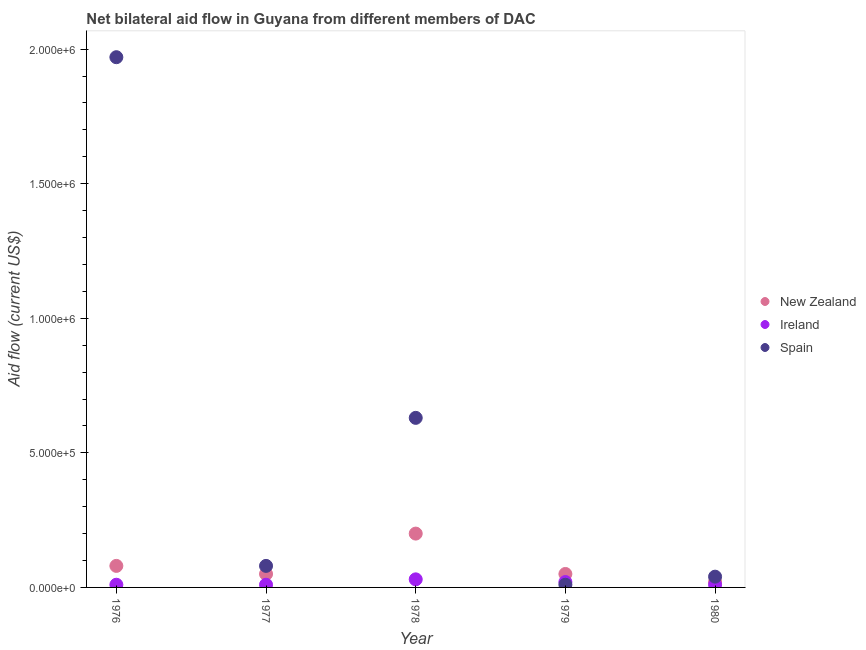How many different coloured dotlines are there?
Ensure brevity in your answer.  3. Is the number of dotlines equal to the number of legend labels?
Keep it short and to the point. Yes. What is the amount of aid provided by ireland in 1978?
Give a very brief answer. 3.00e+04. Across all years, what is the maximum amount of aid provided by ireland?
Keep it short and to the point. 3.00e+04. Across all years, what is the minimum amount of aid provided by new zealand?
Your response must be concise. 2.00e+04. In which year was the amount of aid provided by spain maximum?
Your answer should be very brief. 1976. What is the total amount of aid provided by new zealand in the graph?
Provide a short and direct response. 4.00e+05. What is the difference between the amount of aid provided by ireland in 1977 and that in 1979?
Make the answer very short. -10000. What is the difference between the amount of aid provided by ireland in 1979 and the amount of aid provided by spain in 1980?
Give a very brief answer. -2.00e+04. In the year 1977, what is the difference between the amount of aid provided by new zealand and amount of aid provided by spain?
Offer a very short reply. -3.00e+04. In how many years, is the amount of aid provided by new zealand greater than 500000 US$?
Provide a short and direct response. 0. What is the ratio of the amount of aid provided by ireland in 1976 to that in 1977?
Your response must be concise. 1. Is the amount of aid provided by ireland in 1978 less than that in 1979?
Your answer should be compact. No. Is the difference between the amount of aid provided by ireland in 1978 and 1980 greater than the difference between the amount of aid provided by new zealand in 1978 and 1980?
Make the answer very short. No. What is the difference between the highest and the lowest amount of aid provided by new zealand?
Make the answer very short. 1.80e+05. Is the sum of the amount of aid provided by new zealand in 1977 and 1978 greater than the maximum amount of aid provided by ireland across all years?
Offer a very short reply. Yes. Is it the case that in every year, the sum of the amount of aid provided by new zealand and amount of aid provided by ireland is greater than the amount of aid provided by spain?
Your answer should be very brief. No. Is the amount of aid provided by ireland strictly greater than the amount of aid provided by new zealand over the years?
Your answer should be very brief. No. Is the amount of aid provided by ireland strictly less than the amount of aid provided by spain over the years?
Provide a succinct answer. No. How many dotlines are there?
Give a very brief answer. 3. How many years are there in the graph?
Provide a succinct answer. 5. How many legend labels are there?
Offer a very short reply. 3. How are the legend labels stacked?
Your response must be concise. Vertical. What is the title of the graph?
Provide a short and direct response. Net bilateral aid flow in Guyana from different members of DAC. Does "Ages 50+" appear as one of the legend labels in the graph?
Your response must be concise. No. What is the label or title of the X-axis?
Ensure brevity in your answer.  Year. What is the Aid flow (current US$) in New Zealand in 1976?
Give a very brief answer. 8.00e+04. What is the Aid flow (current US$) of Ireland in 1976?
Provide a succinct answer. 10000. What is the Aid flow (current US$) in Spain in 1976?
Make the answer very short. 1.97e+06. What is the Aid flow (current US$) in New Zealand in 1977?
Ensure brevity in your answer.  5.00e+04. What is the Aid flow (current US$) of Spain in 1977?
Offer a terse response. 8.00e+04. What is the Aid flow (current US$) in New Zealand in 1978?
Give a very brief answer. 2.00e+05. What is the Aid flow (current US$) of Ireland in 1978?
Offer a very short reply. 3.00e+04. What is the Aid flow (current US$) of Spain in 1978?
Offer a terse response. 6.30e+05. What is the Aid flow (current US$) of New Zealand in 1979?
Provide a succinct answer. 5.00e+04. What is the Aid flow (current US$) in Ireland in 1979?
Give a very brief answer. 2.00e+04. What is the Aid flow (current US$) of New Zealand in 1980?
Ensure brevity in your answer.  2.00e+04. What is the Aid flow (current US$) of Spain in 1980?
Give a very brief answer. 4.00e+04. Across all years, what is the maximum Aid flow (current US$) of New Zealand?
Keep it short and to the point. 2.00e+05. Across all years, what is the maximum Aid flow (current US$) in Ireland?
Your answer should be compact. 3.00e+04. Across all years, what is the maximum Aid flow (current US$) in Spain?
Offer a very short reply. 1.97e+06. Across all years, what is the minimum Aid flow (current US$) of New Zealand?
Your answer should be very brief. 2.00e+04. What is the total Aid flow (current US$) in Ireland in the graph?
Provide a succinct answer. 8.00e+04. What is the total Aid flow (current US$) in Spain in the graph?
Provide a short and direct response. 2.73e+06. What is the difference between the Aid flow (current US$) in New Zealand in 1976 and that in 1977?
Provide a succinct answer. 3.00e+04. What is the difference between the Aid flow (current US$) in Ireland in 1976 and that in 1977?
Make the answer very short. 0. What is the difference between the Aid flow (current US$) in Spain in 1976 and that in 1977?
Keep it short and to the point. 1.89e+06. What is the difference between the Aid flow (current US$) of New Zealand in 1976 and that in 1978?
Your answer should be compact. -1.20e+05. What is the difference between the Aid flow (current US$) in Spain in 1976 and that in 1978?
Provide a succinct answer. 1.34e+06. What is the difference between the Aid flow (current US$) in New Zealand in 1976 and that in 1979?
Provide a short and direct response. 3.00e+04. What is the difference between the Aid flow (current US$) in Ireland in 1976 and that in 1979?
Offer a very short reply. -10000. What is the difference between the Aid flow (current US$) of Spain in 1976 and that in 1979?
Your answer should be very brief. 1.96e+06. What is the difference between the Aid flow (current US$) of New Zealand in 1976 and that in 1980?
Provide a short and direct response. 6.00e+04. What is the difference between the Aid flow (current US$) of Spain in 1976 and that in 1980?
Ensure brevity in your answer.  1.93e+06. What is the difference between the Aid flow (current US$) of Spain in 1977 and that in 1978?
Offer a very short reply. -5.50e+05. What is the difference between the Aid flow (current US$) in New Zealand in 1977 and that in 1979?
Offer a terse response. 0. What is the difference between the Aid flow (current US$) of Ireland in 1977 and that in 1979?
Provide a short and direct response. -10000. What is the difference between the Aid flow (current US$) of Spain in 1977 and that in 1979?
Your response must be concise. 7.00e+04. What is the difference between the Aid flow (current US$) in New Zealand in 1977 and that in 1980?
Make the answer very short. 3.00e+04. What is the difference between the Aid flow (current US$) in Ireland in 1977 and that in 1980?
Provide a short and direct response. 0. What is the difference between the Aid flow (current US$) of Spain in 1977 and that in 1980?
Your response must be concise. 4.00e+04. What is the difference between the Aid flow (current US$) in New Zealand in 1978 and that in 1979?
Keep it short and to the point. 1.50e+05. What is the difference between the Aid flow (current US$) in Ireland in 1978 and that in 1979?
Your answer should be very brief. 10000. What is the difference between the Aid flow (current US$) in Spain in 1978 and that in 1979?
Give a very brief answer. 6.20e+05. What is the difference between the Aid flow (current US$) in New Zealand in 1978 and that in 1980?
Provide a succinct answer. 1.80e+05. What is the difference between the Aid flow (current US$) in Spain in 1978 and that in 1980?
Your answer should be very brief. 5.90e+05. What is the difference between the Aid flow (current US$) in Spain in 1979 and that in 1980?
Offer a terse response. -3.00e+04. What is the difference between the Aid flow (current US$) in New Zealand in 1976 and the Aid flow (current US$) in Spain in 1977?
Your answer should be compact. 0. What is the difference between the Aid flow (current US$) in Ireland in 1976 and the Aid flow (current US$) in Spain in 1977?
Your answer should be very brief. -7.00e+04. What is the difference between the Aid flow (current US$) in New Zealand in 1976 and the Aid flow (current US$) in Ireland in 1978?
Ensure brevity in your answer.  5.00e+04. What is the difference between the Aid flow (current US$) in New Zealand in 1976 and the Aid flow (current US$) in Spain in 1978?
Ensure brevity in your answer.  -5.50e+05. What is the difference between the Aid flow (current US$) of Ireland in 1976 and the Aid flow (current US$) of Spain in 1978?
Offer a terse response. -6.20e+05. What is the difference between the Aid flow (current US$) of New Zealand in 1976 and the Aid flow (current US$) of Spain in 1979?
Offer a very short reply. 7.00e+04. What is the difference between the Aid flow (current US$) of Ireland in 1976 and the Aid flow (current US$) of Spain in 1979?
Offer a terse response. 0. What is the difference between the Aid flow (current US$) in New Zealand in 1976 and the Aid flow (current US$) in Spain in 1980?
Give a very brief answer. 4.00e+04. What is the difference between the Aid flow (current US$) in Ireland in 1976 and the Aid flow (current US$) in Spain in 1980?
Provide a succinct answer. -3.00e+04. What is the difference between the Aid flow (current US$) in New Zealand in 1977 and the Aid flow (current US$) in Ireland in 1978?
Keep it short and to the point. 2.00e+04. What is the difference between the Aid flow (current US$) in New Zealand in 1977 and the Aid flow (current US$) in Spain in 1978?
Provide a short and direct response. -5.80e+05. What is the difference between the Aid flow (current US$) of Ireland in 1977 and the Aid flow (current US$) of Spain in 1978?
Ensure brevity in your answer.  -6.20e+05. What is the difference between the Aid flow (current US$) in New Zealand in 1977 and the Aid flow (current US$) in Ireland in 1979?
Provide a short and direct response. 3.00e+04. What is the difference between the Aid flow (current US$) of New Zealand in 1977 and the Aid flow (current US$) of Spain in 1979?
Ensure brevity in your answer.  4.00e+04. What is the difference between the Aid flow (current US$) in New Zealand in 1977 and the Aid flow (current US$) in Ireland in 1980?
Provide a succinct answer. 4.00e+04. What is the difference between the Aid flow (current US$) in New Zealand in 1978 and the Aid flow (current US$) in Spain in 1979?
Your answer should be compact. 1.90e+05. What is the difference between the Aid flow (current US$) of Ireland in 1978 and the Aid flow (current US$) of Spain in 1979?
Give a very brief answer. 2.00e+04. What is the difference between the Aid flow (current US$) of New Zealand in 1978 and the Aid flow (current US$) of Ireland in 1980?
Offer a terse response. 1.90e+05. What is the difference between the Aid flow (current US$) of Ireland in 1978 and the Aid flow (current US$) of Spain in 1980?
Your answer should be very brief. -10000. What is the average Aid flow (current US$) of Ireland per year?
Offer a terse response. 1.60e+04. What is the average Aid flow (current US$) of Spain per year?
Offer a terse response. 5.46e+05. In the year 1976, what is the difference between the Aid flow (current US$) of New Zealand and Aid flow (current US$) of Ireland?
Your response must be concise. 7.00e+04. In the year 1976, what is the difference between the Aid flow (current US$) in New Zealand and Aid flow (current US$) in Spain?
Give a very brief answer. -1.89e+06. In the year 1976, what is the difference between the Aid flow (current US$) in Ireland and Aid flow (current US$) in Spain?
Offer a very short reply. -1.96e+06. In the year 1977, what is the difference between the Aid flow (current US$) of New Zealand and Aid flow (current US$) of Spain?
Your response must be concise. -3.00e+04. In the year 1977, what is the difference between the Aid flow (current US$) in Ireland and Aid flow (current US$) in Spain?
Offer a terse response. -7.00e+04. In the year 1978, what is the difference between the Aid flow (current US$) of New Zealand and Aid flow (current US$) of Ireland?
Your answer should be compact. 1.70e+05. In the year 1978, what is the difference between the Aid flow (current US$) of New Zealand and Aid flow (current US$) of Spain?
Provide a short and direct response. -4.30e+05. In the year 1978, what is the difference between the Aid flow (current US$) in Ireland and Aid flow (current US$) in Spain?
Give a very brief answer. -6.00e+05. In the year 1979, what is the difference between the Aid flow (current US$) of New Zealand and Aid flow (current US$) of Ireland?
Offer a terse response. 3.00e+04. In the year 1979, what is the difference between the Aid flow (current US$) in Ireland and Aid flow (current US$) in Spain?
Make the answer very short. 10000. In the year 1980, what is the difference between the Aid flow (current US$) in New Zealand and Aid flow (current US$) in Ireland?
Offer a terse response. 10000. What is the ratio of the Aid flow (current US$) of Spain in 1976 to that in 1977?
Keep it short and to the point. 24.62. What is the ratio of the Aid flow (current US$) in New Zealand in 1976 to that in 1978?
Offer a very short reply. 0.4. What is the ratio of the Aid flow (current US$) of Spain in 1976 to that in 1978?
Provide a succinct answer. 3.13. What is the ratio of the Aid flow (current US$) of New Zealand in 1976 to that in 1979?
Offer a terse response. 1.6. What is the ratio of the Aid flow (current US$) in Spain in 1976 to that in 1979?
Your answer should be compact. 197. What is the ratio of the Aid flow (current US$) of New Zealand in 1976 to that in 1980?
Give a very brief answer. 4. What is the ratio of the Aid flow (current US$) of Ireland in 1976 to that in 1980?
Your response must be concise. 1. What is the ratio of the Aid flow (current US$) of Spain in 1976 to that in 1980?
Make the answer very short. 49.25. What is the ratio of the Aid flow (current US$) of New Zealand in 1977 to that in 1978?
Offer a very short reply. 0.25. What is the ratio of the Aid flow (current US$) in Ireland in 1977 to that in 1978?
Your answer should be very brief. 0.33. What is the ratio of the Aid flow (current US$) of Spain in 1977 to that in 1978?
Offer a terse response. 0.13. What is the ratio of the Aid flow (current US$) in Ireland in 1977 to that in 1979?
Your answer should be compact. 0.5. What is the ratio of the Aid flow (current US$) of Spain in 1977 to that in 1979?
Make the answer very short. 8. What is the ratio of the Aid flow (current US$) in New Zealand in 1977 to that in 1980?
Your answer should be compact. 2.5. What is the ratio of the Aid flow (current US$) in Spain in 1977 to that in 1980?
Your response must be concise. 2. What is the ratio of the Aid flow (current US$) in Ireland in 1978 to that in 1979?
Keep it short and to the point. 1.5. What is the ratio of the Aid flow (current US$) in Spain in 1978 to that in 1979?
Offer a terse response. 63. What is the ratio of the Aid flow (current US$) of New Zealand in 1978 to that in 1980?
Provide a succinct answer. 10. What is the ratio of the Aid flow (current US$) in Spain in 1978 to that in 1980?
Provide a succinct answer. 15.75. What is the ratio of the Aid flow (current US$) of New Zealand in 1979 to that in 1980?
Keep it short and to the point. 2.5. What is the ratio of the Aid flow (current US$) in Ireland in 1979 to that in 1980?
Give a very brief answer. 2. What is the ratio of the Aid flow (current US$) of Spain in 1979 to that in 1980?
Your response must be concise. 0.25. What is the difference between the highest and the second highest Aid flow (current US$) of New Zealand?
Your answer should be compact. 1.20e+05. What is the difference between the highest and the second highest Aid flow (current US$) of Ireland?
Provide a succinct answer. 10000. What is the difference between the highest and the second highest Aid flow (current US$) of Spain?
Keep it short and to the point. 1.34e+06. What is the difference between the highest and the lowest Aid flow (current US$) in New Zealand?
Ensure brevity in your answer.  1.80e+05. What is the difference between the highest and the lowest Aid flow (current US$) of Spain?
Your response must be concise. 1.96e+06. 